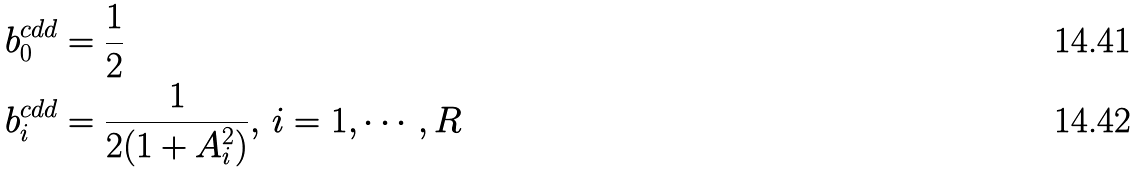<formula> <loc_0><loc_0><loc_500><loc_500>b _ { 0 } ^ { c d d } & = \frac { 1 } { 2 } \\ b _ { i } ^ { c d d } & = \frac { 1 } { 2 ( 1 + A _ { i } ^ { 2 } ) } , \, i = 1 , \cdots , R</formula> 